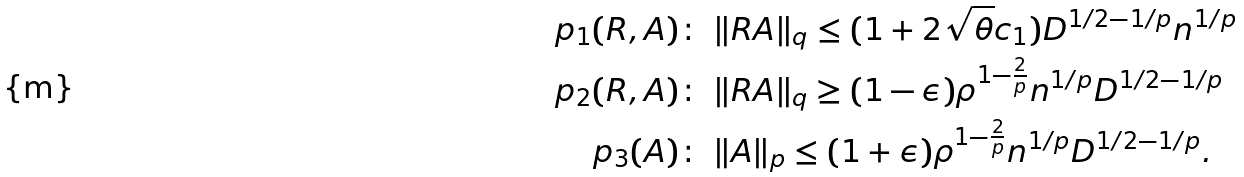<formula> <loc_0><loc_0><loc_500><loc_500>\ p _ { 1 } ( R , A ) \colon \ & \| R A \| _ { q } \leq ( 1 + 2 \sqrt { \theta } c _ { 1 } ) D ^ { 1 / 2 - 1 / p } n ^ { 1 / p } \\ \ p _ { 2 } ( R , A ) \colon \ & \| R A \| _ { q } \geq ( 1 - \epsilon ) \rho ^ { 1 - \frac { 2 } { p } } n ^ { 1 / p } D ^ { 1 / 2 - 1 / p } \\ \ p _ { 3 } ( A ) \colon \ & \| A \| _ { p } \leq ( 1 + \epsilon ) \rho ^ { 1 - \frac { 2 } { p } } n ^ { 1 / p } D ^ { 1 / 2 - 1 / p } .</formula> 